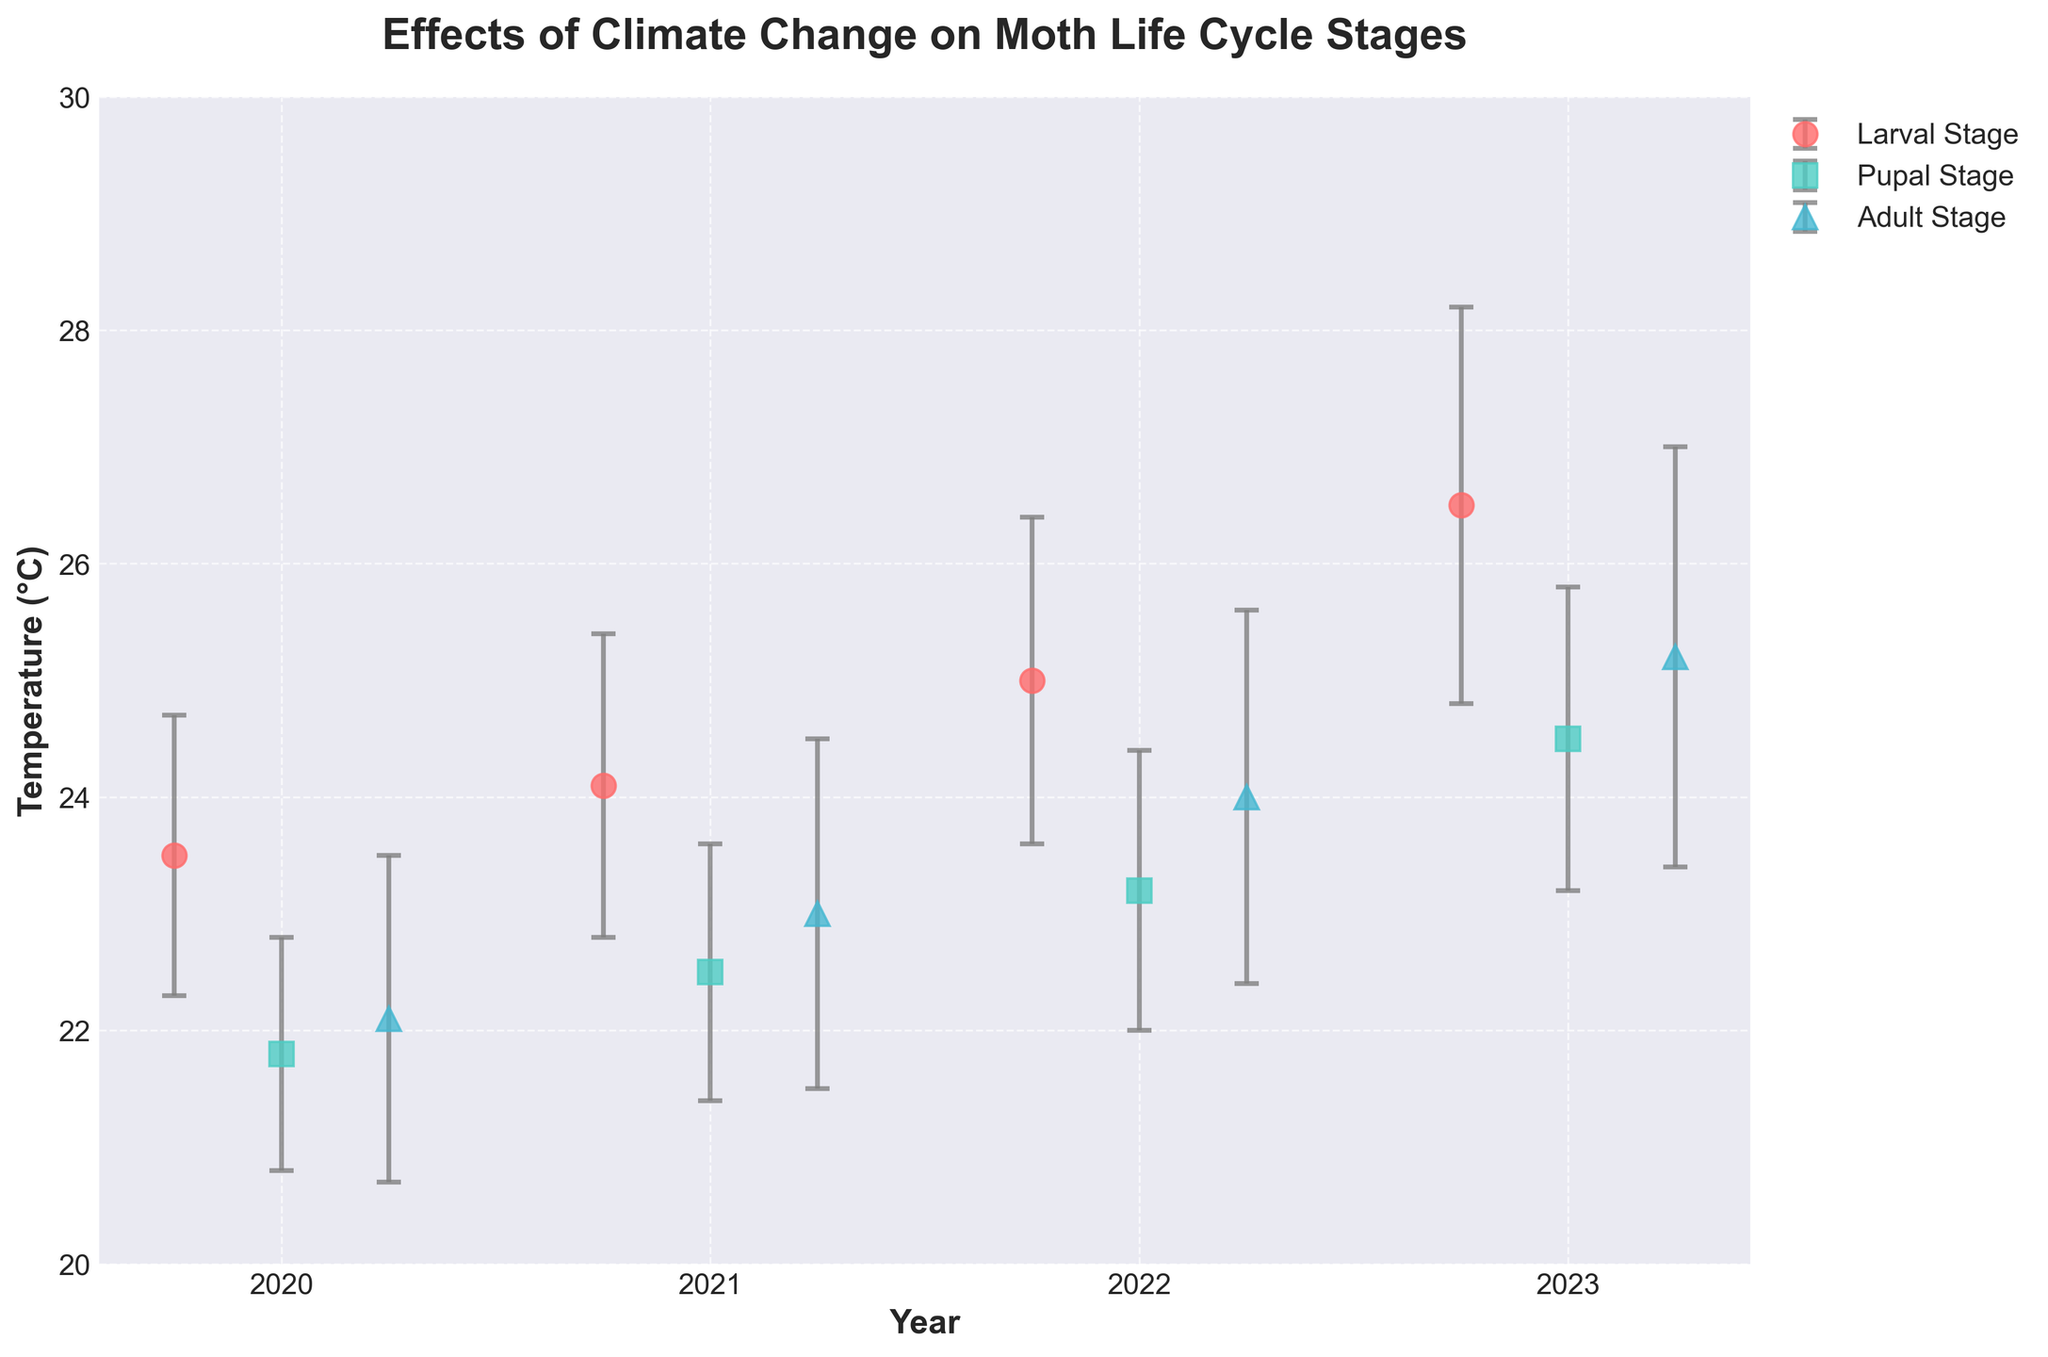What is the title of the plot? The title of the plot is usually placed at the top of the figure. In this case, you can refer to the top of the figure where the title is explicitly mentioned.
Answer: Effects of Climate Change on Moth Life Cycle Stages What are the x-axis and y-axis labels? The x-axis and y-axis labels typically appear at the bottom and the left side of the plot respectively. You can directly read them off the plot.
Answer: Year, Temperature (°C) Which life cycle stage had the highest mean temperature in 2023? To answer this, inspect the data points and corresponding error bars for the year 2023. The one with the highest mean temperature value represents the stage with the highest mean temperature.
Answer: Larval Stage What is the mean temperature value and error margin for the Pupal Stage in 2022? Look for the data corresponding to the Pupal Stage for the year 2022. The associated mean temperature value and error margin are illustrated by the error bar on the plot.
Answer: Mean Temperature: 23.2°C, Error Margin: 1.2°C What is the general trend of the mean temperature for the Larval Stage from 2020 to 2023? To evaluate the trend, observe the positions of the data points for the Larval Stage from 2020 to 2023. The mean temperature seems to increase over these years.
Answer: Increasing trend How does the error margin for the Adult Stage compare between 2021 and 2023? Compare the lengths of the error bars for the Adult Stage in the years 2021 and 2023. The error margin is visually represented by the height of the error bars.
Answer: The error margin is larger in 2023 Which year observed the highest mean temperature across all life cycle stages? To find the year with the highest mean temperature, inspect and compare the highest data points across all stages for each year.
Answer: 2023 By how much did the mean temperature for the Larval Stage increase from 2021 to 2023? First, identify the mean temperature for the Larval Stage in 2021 and 2023. Then subtract the 2021 value from the 2023 value.
Answer: 26.5°C - 24.1°C = 2.4°C Which life cycle stage in 2020 had the smallest error margin? Compare the error margins across all stages in the year 2020 by checking the lengths of their respective error bars.
Answer: Pupal Stage Is the mean temperature for the Adult Stage higher in 2021 or in 2022? Compare the mean temperature values of the Adult Stage for the years 2021 and 2022.
Answer: Higher in 2022 